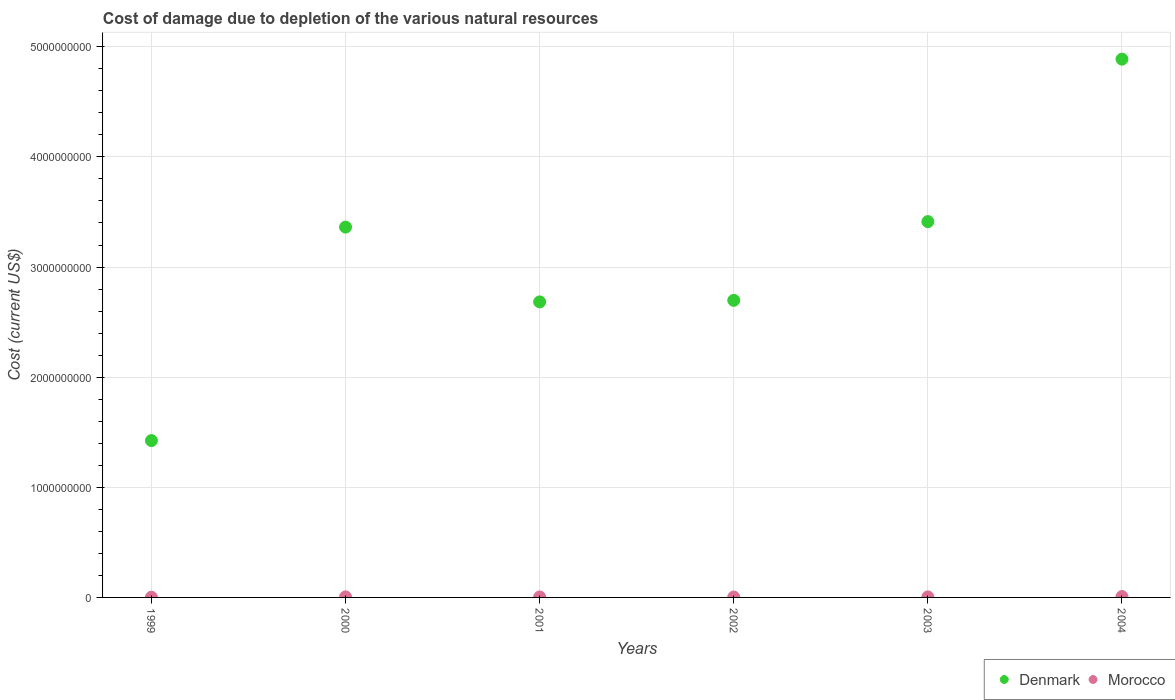What is the cost of damage caused due to the depletion of various natural resources in Denmark in 2000?
Offer a terse response. 3.36e+09. Across all years, what is the maximum cost of damage caused due to the depletion of various natural resources in Morocco?
Your answer should be compact. 7.78e+06. Across all years, what is the minimum cost of damage caused due to the depletion of various natural resources in Denmark?
Provide a succinct answer. 1.42e+09. In which year was the cost of damage caused due to the depletion of various natural resources in Denmark maximum?
Your response must be concise. 2004. What is the total cost of damage caused due to the depletion of various natural resources in Morocco in the graph?
Ensure brevity in your answer.  2.74e+07. What is the difference between the cost of damage caused due to the depletion of various natural resources in Morocco in 2001 and that in 2002?
Make the answer very short. 5.11e+05. What is the difference between the cost of damage caused due to the depletion of various natural resources in Denmark in 2002 and the cost of damage caused due to the depletion of various natural resources in Morocco in 2003?
Make the answer very short. 2.69e+09. What is the average cost of damage caused due to the depletion of various natural resources in Morocco per year?
Provide a short and direct response. 4.57e+06. In the year 1999, what is the difference between the cost of damage caused due to the depletion of various natural resources in Morocco and cost of damage caused due to the depletion of various natural resources in Denmark?
Make the answer very short. -1.42e+09. What is the ratio of the cost of damage caused due to the depletion of various natural resources in Morocco in 2000 to that in 2001?
Offer a very short reply. 1.19. Is the difference between the cost of damage caused due to the depletion of various natural resources in Morocco in 2000 and 2003 greater than the difference between the cost of damage caused due to the depletion of various natural resources in Denmark in 2000 and 2003?
Offer a terse response. Yes. What is the difference between the highest and the second highest cost of damage caused due to the depletion of various natural resources in Morocco?
Your response must be concise. 2.77e+06. What is the difference between the highest and the lowest cost of damage caused due to the depletion of various natural resources in Denmark?
Ensure brevity in your answer.  3.46e+09. In how many years, is the cost of damage caused due to the depletion of various natural resources in Morocco greater than the average cost of damage caused due to the depletion of various natural resources in Morocco taken over all years?
Your answer should be very brief. 3. Does the cost of damage caused due to the depletion of various natural resources in Morocco monotonically increase over the years?
Make the answer very short. No. How many dotlines are there?
Offer a terse response. 2. What is the difference between two consecutive major ticks on the Y-axis?
Ensure brevity in your answer.  1.00e+09. Are the values on the major ticks of Y-axis written in scientific E-notation?
Provide a succinct answer. No. Does the graph contain any zero values?
Your response must be concise. No. Does the graph contain grids?
Ensure brevity in your answer.  Yes. How many legend labels are there?
Your answer should be compact. 2. How are the legend labels stacked?
Offer a very short reply. Horizontal. What is the title of the graph?
Keep it short and to the point. Cost of damage due to depletion of the various natural resources. What is the label or title of the X-axis?
Ensure brevity in your answer.  Years. What is the label or title of the Y-axis?
Keep it short and to the point. Cost (current US$). What is the Cost (current US$) of Denmark in 1999?
Your response must be concise. 1.42e+09. What is the Cost (current US$) of Morocco in 1999?
Provide a succinct answer. 1.89e+06. What is the Cost (current US$) of Denmark in 2000?
Your response must be concise. 3.36e+09. What is the Cost (current US$) of Morocco in 2000?
Give a very brief answer. 5.01e+06. What is the Cost (current US$) of Denmark in 2001?
Your response must be concise. 2.68e+09. What is the Cost (current US$) of Morocco in 2001?
Your answer should be compact. 4.21e+06. What is the Cost (current US$) in Denmark in 2002?
Your answer should be very brief. 2.70e+09. What is the Cost (current US$) of Morocco in 2002?
Your answer should be very brief. 3.70e+06. What is the Cost (current US$) in Denmark in 2003?
Your response must be concise. 3.41e+09. What is the Cost (current US$) in Morocco in 2003?
Keep it short and to the point. 4.85e+06. What is the Cost (current US$) in Denmark in 2004?
Your answer should be very brief. 4.89e+09. What is the Cost (current US$) in Morocco in 2004?
Ensure brevity in your answer.  7.78e+06. Across all years, what is the maximum Cost (current US$) in Denmark?
Keep it short and to the point. 4.89e+09. Across all years, what is the maximum Cost (current US$) of Morocco?
Provide a short and direct response. 7.78e+06. Across all years, what is the minimum Cost (current US$) of Denmark?
Your answer should be compact. 1.42e+09. Across all years, what is the minimum Cost (current US$) of Morocco?
Your answer should be very brief. 1.89e+06. What is the total Cost (current US$) in Denmark in the graph?
Offer a very short reply. 1.85e+1. What is the total Cost (current US$) in Morocco in the graph?
Offer a very short reply. 2.74e+07. What is the difference between the Cost (current US$) in Denmark in 1999 and that in 2000?
Your answer should be very brief. -1.94e+09. What is the difference between the Cost (current US$) of Morocco in 1999 and that in 2000?
Your answer should be compact. -3.13e+06. What is the difference between the Cost (current US$) in Denmark in 1999 and that in 2001?
Make the answer very short. -1.26e+09. What is the difference between the Cost (current US$) in Morocco in 1999 and that in 2001?
Keep it short and to the point. -2.32e+06. What is the difference between the Cost (current US$) of Denmark in 1999 and that in 2002?
Your answer should be compact. -1.27e+09. What is the difference between the Cost (current US$) in Morocco in 1999 and that in 2002?
Your answer should be compact. -1.81e+06. What is the difference between the Cost (current US$) in Denmark in 1999 and that in 2003?
Your answer should be compact. -1.99e+09. What is the difference between the Cost (current US$) of Morocco in 1999 and that in 2003?
Offer a very short reply. -2.96e+06. What is the difference between the Cost (current US$) in Denmark in 1999 and that in 2004?
Give a very brief answer. -3.46e+09. What is the difference between the Cost (current US$) in Morocco in 1999 and that in 2004?
Your answer should be very brief. -5.90e+06. What is the difference between the Cost (current US$) of Denmark in 2000 and that in 2001?
Provide a succinct answer. 6.79e+08. What is the difference between the Cost (current US$) of Morocco in 2000 and that in 2001?
Provide a short and direct response. 8.06e+05. What is the difference between the Cost (current US$) in Denmark in 2000 and that in 2002?
Keep it short and to the point. 6.65e+08. What is the difference between the Cost (current US$) of Morocco in 2000 and that in 2002?
Give a very brief answer. 1.32e+06. What is the difference between the Cost (current US$) of Denmark in 2000 and that in 2003?
Your answer should be compact. -4.98e+07. What is the difference between the Cost (current US$) in Morocco in 2000 and that in 2003?
Your response must be concise. 1.66e+05. What is the difference between the Cost (current US$) of Denmark in 2000 and that in 2004?
Your answer should be very brief. -1.53e+09. What is the difference between the Cost (current US$) in Morocco in 2000 and that in 2004?
Provide a succinct answer. -2.77e+06. What is the difference between the Cost (current US$) in Denmark in 2001 and that in 2002?
Your response must be concise. -1.40e+07. What is the difference between the Cost (current US$) in Morocco in 2001 and that in 2002?
Offer a very short reply. 5.11e+05. What is the difference between the Cost (current US$) in Denmark in 2001 and that in 2003?
Provide a succinct answer. -7.29e+08. What is the difference between the Cost (current US$) in Morocco in 2001 and that in 2003?
Ensure brevity in your answer.  -6.39e+05. What is the difference between the Cost (current US$) of Denmark in 2001 and that in 2004?
Your answer should be very brief. -2.20e+09. What is the difference between the Cost (current US$) in Morocco in 2001 and that in 2004?
Ensure brevity in your answer.  -3.57e+06. What is the difference between the Cost (current US$) of Denmark in 2002 and that in 2003?
Give a very brief answer. -7.15e+08. What is the difference between the Cost (current US$) in Morocco in 2002 and that in 2003?
Offer a very short reply. -1.15e+06. What is the difference between the Cost (current US$) in Denmark in 2002 and that in 2004?
Your response must be concise. -2.19e+09. What is the difference between the Cost (current US$) in Morocco in 2002 and that in 2004?
Make the answer very short. -4.09e+06. What is the difference between the Cost (current US$) of Denmark in 2003 and that in 2004?
Keep it short and to the point. -1.48e+09. What is the difference between the Cost (current US$) of Morocco in 2003 and that in 2004?
Provide a succinct answer. -2.94e+06. What is the difference between the Cost (current US$) of Denmark in 1999 and the Cost (current US$) of Morocco in 2000?
Your answer should be compact. 1.42e+09. What is the difference between the Cost (current US$) in Denmark in 1999 and the Cost (current US$) in Morocco in 2001?
Give a very brief answer. 1.42e+09. What is the difference between the Cost (current US$) in Denmark in 1999 and the Cost (current US$) in Morocco in 2002?
Your answer should be very brief. 1.42e+09. What is the difference between the Cost (current US$) of Denmark in 1999 and the Cost (current US$) of Morocco in 2003?
Offer a very short reply. 1.42e+09. What is the difference between the Cost (current US$) in Denmark in 1999 and the Cost (current US$) in Morocco in 2004?
Your answer should be compact. 1.42e+09. What is the difference between the Cost (current US$) in Denmark in 2000 and the Cost (current US$) in Morocco in 2001?
Offer a terse response. 3.36e+09. What is the difference between the Cost (current US$) in Denmark in 2000 and the Cost (current US$) in Morocco in 2002?
Your answer should be compact. 3.36e+09. What is the difference between the Cost (current US$) in Denmark in 2000 and the Cost (current US$) in Morocco in 2003?
Keep it short and to the point. 3.36e+09. What is the difference between the Cost (current US$) in Denmark in 2000 and the Cost (current US$) in Morocco in 2004?
Give a very brief answer. 3.35e+09. What is the difference between the Cost (current US$) in Denmark in 2001 and the Cost (current US$) in Morocco in 2002?
Make the answer very short. 2.68e+09. What is the difference between the Cost (current US$) in Denmark in 2001 and the Cost (current US$) in Morocco in 2003?
Your response must be concise. 2.68e+09. What is the difference between the Cost (current US$) of Denmark in 2001 and the Cost (current US$) of Morocco in 2004?
Your response must be concise. 2.68e+09. What is the difference between the Cost (current US$) of Denmark in 2002 and the Cost (current US$) of Morocco in 2003?
Your answer should be very brief. 2.69e+09. What is the difference between the Cost (current US$) of Denmark in 2002 and the Cost (current US$) of Morocco in 2004?
Provide a succinct answer. 2.69e+09. What is the difference between the Cost (current US$) in Denmark in 2003 and the Cost (current US$) in Morocco in 2004?
Provide a short and direct response. 3.40e+09. What is the average Cost (current US$) in Denmark per year?
Provide a short and direct response. 3.08e+09. What is the average Cost (current US$) in Morocco per year?
Your answer should be compact. 4.57e+06. In the year 1999, what is the difference between the Cost (current US$) of Denmark and Cost (current US$) of Morocco?
Provide a short and direct response. 1.42e+09. In the year 2000, what is the difference between the Cost (current US$) of Denmark and Cost (current US$) of Morocco?
Offer a very short reply. 3.36e+09. In the year 2001, what is the difference between the Cost (current US$) in Denmark and Cost (current US$) in Morocco?
Give a very brief answer. 2.68e+09. In the year 2002, what is the difference between the Cost (current US$) in Denmark and Cost (current US$) in Morocco?
Make the answer very short. 2.69e+09. In the year 2003, what is the difference between the Cost (current US$) in Denmark and Cost (current US$) in Morocco?
Ensure brevity in your answer.  3.41e+09. In the year 2004, what is the difference between the Cost (current US$) of Denmark and Cost (current US$) of Morocco?
Ensure brevity in your answer.  4.88e+09. What is the ratio of the Cost (current US$) in Denmark in 1999 to that in 2000?
Offer a terse response. 0.42. What is the ratio of the Cost (current US$) in Morocco in 1999 to that in 2000?
Give a very brief answer. 0.38. What is the ratio of the Cost (current US$) of Denmark in 1999 to that in 2001?
Ensure brevity in your answer.  0.53. What is the ratio of the Cost (current US$) in Morocco in 1999 to that in 2001?
Provide a short and direct response. 0.45. What is the ratio of the Cost (current US$) of Denmark in 1999 to that in 2002?
Your answer should be very brief. 0.53. What is the ratio of the Cost (current US$) in Morocco in 1999 to that in 2002?
Provide a short and direct response. 0.51. What is the ratio of the Cost (current US$) of Denmark in 1999 to that in 2003?
Ensure brevity in your answer.  0.42. What is the ratio of the Cost (current US$) of Morocco in 1999 to that in 2003?
Make the answer very short. 0.39. What is the ratio of the Cost (current US$) of Denmark in 1999 to that in 2004?
Your answer should be very brief. 0.29. What is the ratio of the Cost (current US$) of Morocco in 1999 to that in 2004?
Give a very brief answer. 0.24. What is the ratio of the Cost (current US$) of Denmark in 2000 to that in 2001?
Keep it short and to the point. 1.25. What is the ratio of the Cost (current US$) in Morocco in 2000 to that in 2001?
Keep it short and to the point. 1.19. What is the ratio of the Cost (current US$) of Denmark in 2000 to that in 2002?
Make the answer very short. 1.25. What is the ratio of the Cost (current US$) of Morocco in 2000 to that in 2002?
Ensure brevity in your answer.  1.36. What is the ratio of the Cost (current US$) of Denmark in 2000 to that in 2003?
Offer a terse response. 0.99. What is the ratio of the Cost (current US$) in Morocco in 2000 to that in 2003?
Make the answer very short. 1.03. What is the ratio of the Cost (current US$) of Denmark in 2000 to that in 2004?
Provide a short and direct response. 0.69. What is the ratio of the Cost (current US$) in Morocco in 2000 to that in 2004?
Offer a terse response. 0.64. What is the ratio of the Cost (current US$) of Morocco in 2001 to that in 2002?
Give a very brief answer. 1.14. What is the ratio of the Cost (current US$) of Denmark in 2001 to that in 2003?
Offer a very short reply. 0.79. What is the ratio of the Cost (current US$) in Morocco in 2001 to that in 2003?
Offer a terse response. 0.87. What is the ratio of the Cost (current US$) of Denmark in 2001 to that in 2004?
Offer a very short reply. 0.55. What is the ratio of the Cost (current US$) of Morocco in 2001 to that in 2004?
Your answer should be very brief. 0.54. What is the ratio of the Cost (current US$) of Denmark in 2002 to that in 2003?
Offer a very short reply. 0.79. What is the ratio of the Cost (current US$) in Morocco in 2002 to that in 2003?
Ensure brevity in your answer.  0.76. What is the ratio of the Cost (current US$) of Denmark in 2002 to that in 2004?
Offer a terse response. 0.55. What is the ratio of the Cost (current US$) of Morocco in 2002 to that in 2004?
Offer a terse response. 0.48. What is the ratio of the Cost (current US$) of Denmark in 2003 to that in 2004?
Your answer should be compact. 0.7. What is the ratio of the Cost (current US$) of Morocco in 2003 to that in 2004?
Provide a succinct answer. 0.62. What is the difference between the highest and the second highest Cost (current US$) in Denmark?
Your answer should be compact. 1.48e+09. What is the difference between the highest and the second highest Cost (current US$) in Morocco?
Your response must be concise. 2.77e+06. What is the difference between the highest and the lowest Cost (current US$) in Denmark?
Your answer should be compact. 3.46e+09. What is the difference between the highest and the lowest Cost (current US$) of Morocco?
Provide a short and direct response. 5.90e+06. 